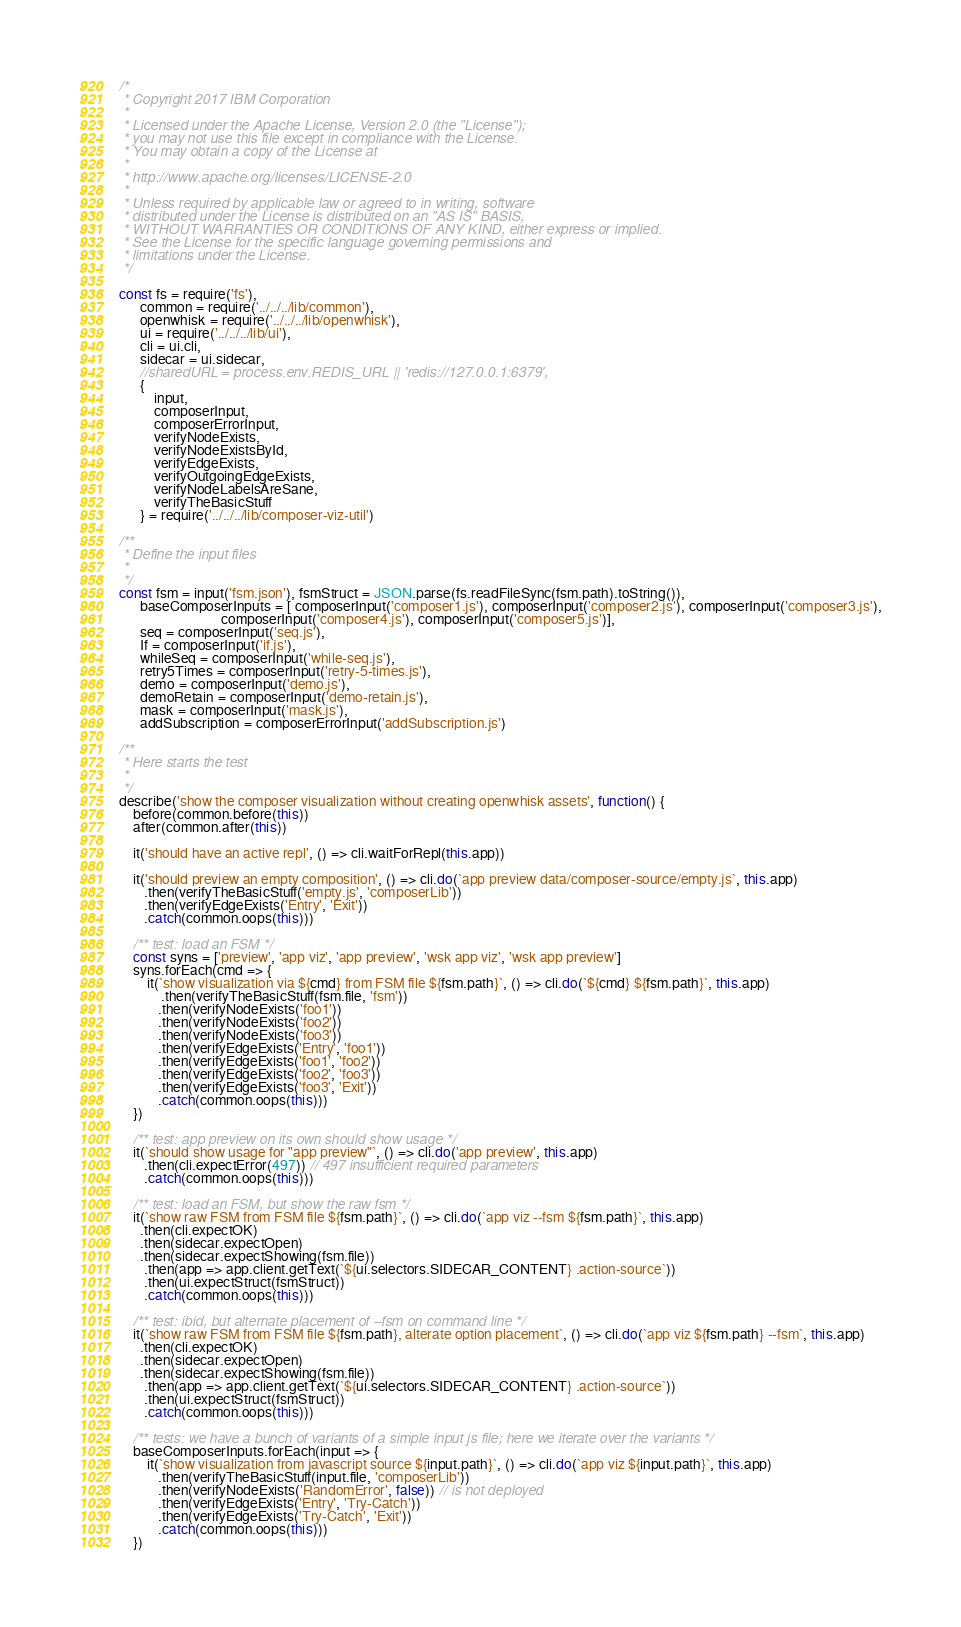<code> <loc_0><loc_0><loc_500><loc_500><_JavaScript_>/*
 * Copyright 2017 IBM Corporation
 *
 * Licensed under the Apache License, Version 2.0 (the "License");
 * you may not use this file except in compliance with the License.
 * You may obtain a copy of the License at
 *
 * http://www.apache.org/licenses/LICENSE-2.0
 *
 * Unless required by applicable law or agreed to in writing, software
 * distributed under the License is distributed on an "AS IS" BASIS,
 * WITHOUT WARRANTIES OR CONDITIONS OF ANY KIND, either express or implied.
 * See the License for the specific language governing permissions and
 * limitations under the License.
 */

const fs = require('fs'),
      common = require('../../../lib/common'),
      openwhisk = require('../../../lib/openwhisk'),
      ui = require('../../../lib/ui'),
      cli = ui.cli,
      sidecar = ui.sidecar,
      //sharedURL = process.env.REDIS_URL || 'redis://127.0.0.1:6379',
      {
          input,
          composerInput,
          composerErrorInput,
          verifyNodeExists,
          verifyNodeExistsById,
          verifyEdgeExists,
          verifyOutgoingEdgeExists,
          verifyNodeLabelsAreSane,
          verifyTheBasicStuff
      } = require('../../../lib/composer-viz-util')

/**
 * Define the input files
 *
 */
const fsm = input('fsm.json'), fsmStruct = JSON.parse(fs.readFileSync(fsm.path).toString()),
      baseComposerInputs = [ composerInput('composer1.js'), composerInput('composer2.js'), composerInput('composer3.js'),
                             composerInput('composer4.js'), composerInput('composer5.js')],
      seq = composerInput('seq.js'),
      If = composerInput('if.js'),
      whileSeq = composerInput('while-seq.js'),
      retry5Times = composerInput('retry-5-times.js'),
      demo = composerInput('demo.js'),
      demoRetain = composerInput('demo-retain.js'),
      mask = composerInput('mask.js'),
      addSubscription = composerErrorInput('addSubscription.js')

/**
 * Here starts the test
 *
 */
describe('show the composer visualization without creating openwhisk assets', function() {
    before(common.before(this))
    after(common.after(this))

    it('should have an active repl', () => cli.waitForRepl(this.app))

    it('should preview an empty composition', () => cli.do(`app preview data/composer-source/empty.js`, this.app)
       .then(verifyTheBasicStuff('empty.js', 'composerLib'))
       .then(verifyEdgeExists('Entry', 'Exit'))
       .catch(common.oops(this)))

    /** test: load an FSM */
    const syns = ['preview', 'app viz', 'app preview', 'wsk app viz', 'wsk app preview']
    syns.forEach(cmd => {
        it(`show visualization via ${cmd} from FSM file ${fsm.path}`, () => cli.do(`${cmd} ${fsm.path}`, this.app)
            .then(verifyTheBasicStuff(fsm.file, 'fsm'))
           .then(verifyNodeExists('foo1'))
           .then(verifyNodeExists('foo2'))
           .then(verifyNodeExists('foo3'))
           .then(verifyEdgeExists('Entry', 'foo1'))
           .then(verifyEdgeExists('foo1', 'foo2'))
           .then(verifyEdgeExists('foo2', 'foo3'))
           .then(verifyEdgeExists('foo3', 'Exit'))
           .catch(common.oops(this)))
    })

    /** test: app preview on its own should show usage */
    it(`should show usage for "app preview"`, () => cli.do('app preview', this.app)
       .then(cli.expectError(497)) // 497 insufficient required parameters
       .catch(common.oops(this)))

    /** test: load an FSM, but show the raw fsm */
    it(`show raw FSM from FSM file ${fsm.path}`, () => cli.do(`app viz --fsm ${fsm.path}`, this.app)
      .then(cli.expectOK)
      .then(sidecar.expectOpen)
      .then(sidecar.expectShowing(fsm.file))
       .then(app => app.client.getText(`${ui.selectors.SIDECAR_CONTENT} .action-source`))
       .then(ui.expectStruct(fsmStruct))
       .catch(common.oops(this)))

    /** test: ibid, but alternate placement of --fsm on command line */
    it(`show raw FSM from FSM file ${fsm.path}, alterate option placement`, () => cli.do(`app viz ${fsm.path} --fsm`, this.app)
      .then(cli.expectOK)
      .then(sidecar.expectOpen)
      .then(sidecar.expectShowing(fsm.file))
       .then(app => app.client.getText(`${ui.selectors.SIDECAR_CONTENT} .action-source`))
       .then(ui.expectStruct(fsmStruct))
       .catch(common.oops(this)))

    /** tests: we have a bunch of variants of a simple input js file; here we iterate over the variants */
    baseComposerInputs.forEach(input => {
        it(`show visualization from javascript source ${input.path}`, () => cli.do(`app viz ${input.path}`, this.app)
           .then(verifyTheBasicStuff(input.file, 'composerLib'))
           .then(verifyNodeExists('RandomError', false)) // is not deployed
           .then(verifyEdgeExists('Entry', 'Try-Catch'))
           .then(verifyEdgeExists('Try-Catch', 'Exit'))
           .catch(common.oops(this)))
    })
</code> 